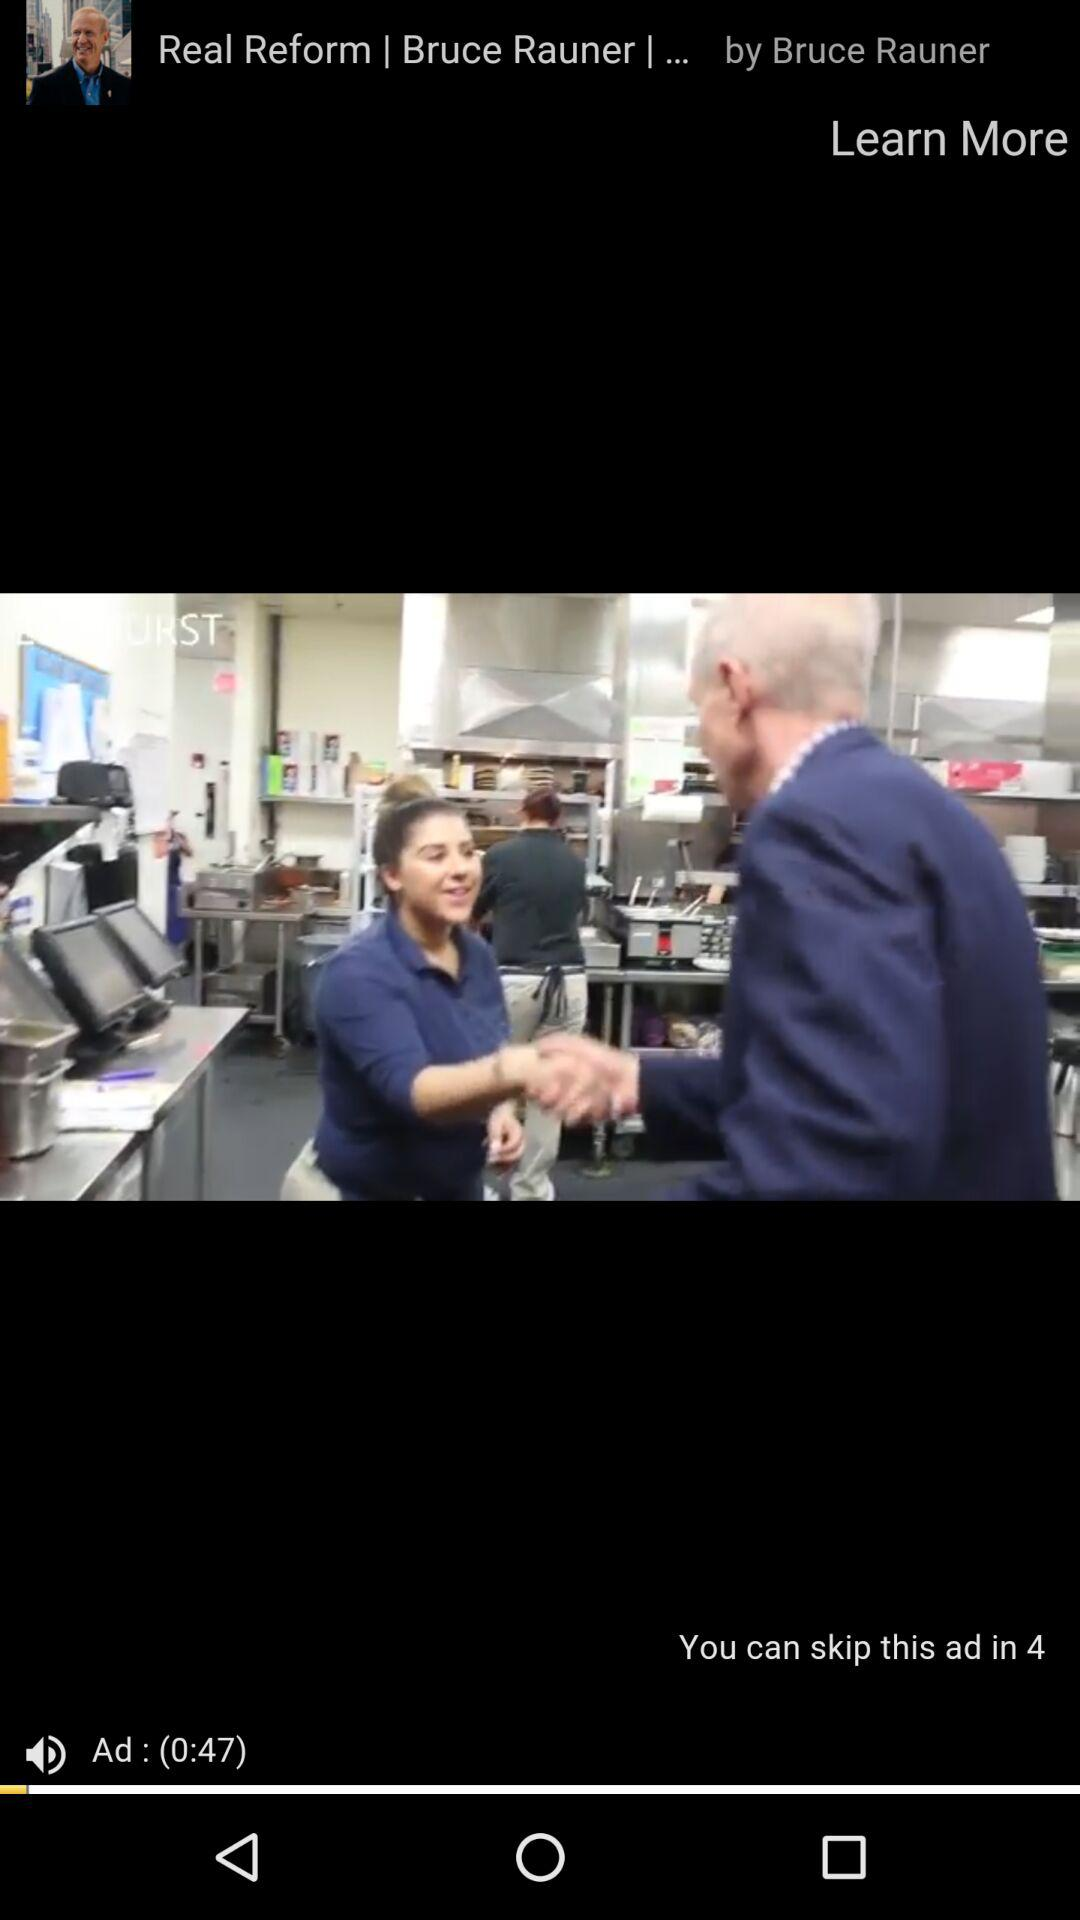How many more seconds until the ad is over?
Answer the question using a single word or phrase. 4 